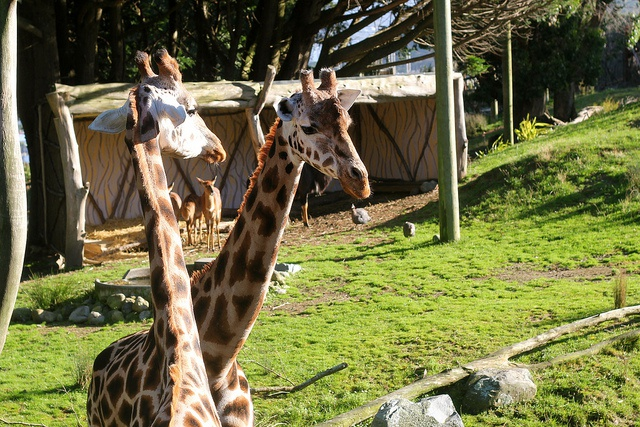Describe the objects in this image and their specific colors. I can see giraffe in black, maroon, and gray tones, giraffe in black, ivory, gray, and tan tones, bird in black, lightgray, darkgray, and tan tones, and bird in black, white, darkgreen, and tan tones in this image. 